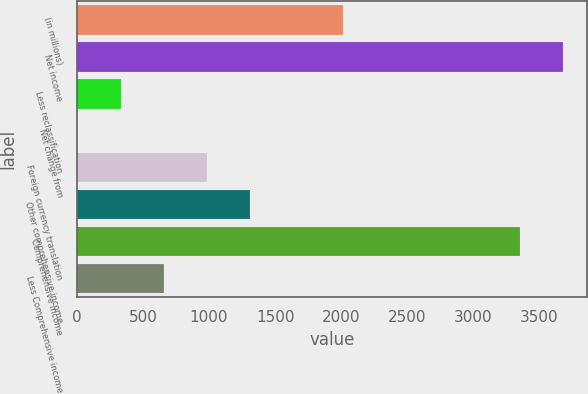<chart> <loc_0><loc_0><loc_500><loc_500><bar_chart><fcel>(in millions)<fcel>Net income<fcel>Less reclassification<fcel>Net change from<fcel>Foreign currency translation<fcel>Other comprehensive income<fcel>Comprehensive income<fcel>Less Comprehensive income<nl><fcel>2014<fcel>3677.8<fcel>330.9<fcel>5<fcel>982.7<fcel>1308.6<fcel>3351.9<fcel>656.8<nl></chart> 